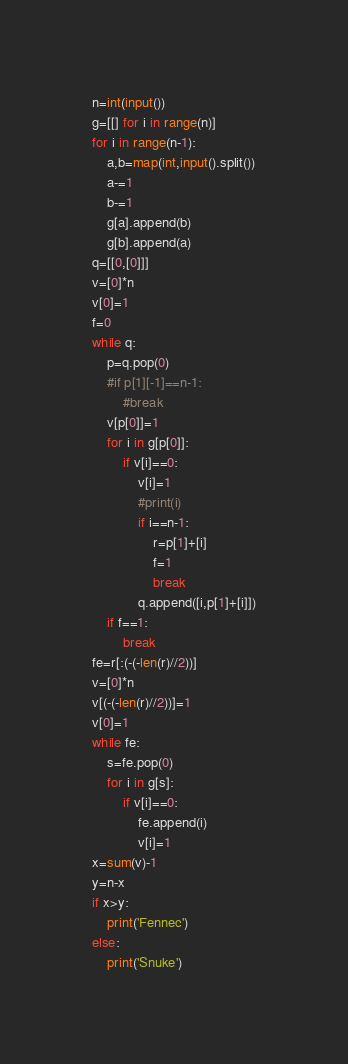<code> <loc_0><loc_0><loc_500><loc_500><_Python_>n=int(input())
g=[[] for i in range(n)]
for i in range(n-1):
    a,b=map(int,input().split())
    a-=1
    b-=1
    g[a].append(b)
    g[b].append(a)
q=[[0,[0]]]
v=[0]*n
v[0]=1
f=0
while q:
    p=q.pop(0)
    #if p[1][-1]==n-1:
        #break
    v[p[0]]=1
    for i in g[p[0]]:
        if v[i]==0:
            v[i]=1
            #print(i)
            if i==n-1:
                r=p[1]+[i]
                f=1
                break
            q.append([i,p[1]+[i]])
    if f==1:
        break
fe=r[:(-(-len(r)//2))]
v=[0]*n
v[(-(-len(r)//2))]=1
v[0]=1
while fe:
    s=fe.pop(0)
    for i in g[s]:
        if v[i]==0:
            fe.append(i)
            v[i]=1
x=sum(v)-1
y=n-x
if x>y:
    print('Fennec')
else:
    print('Snuke')</code> 